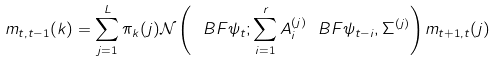<formula> <loc_0><loc_0><loc_500><loc_500>m _ { t , t - 1 } ( k ) = \sum _ { j = 1 } ^ { L } \pi _ { k } ( j ) \mathcal { N } \left ( \ B F { \psi } _ { t } ; \sum _ { i = 1 } ^ { r } A ^ { ( j ) } _ { i } \ B F { \psi } _ { t - i } , \Sigma ^ { ( j ) } \right ) m _ { t + 1 , t } ( j )</formula> 